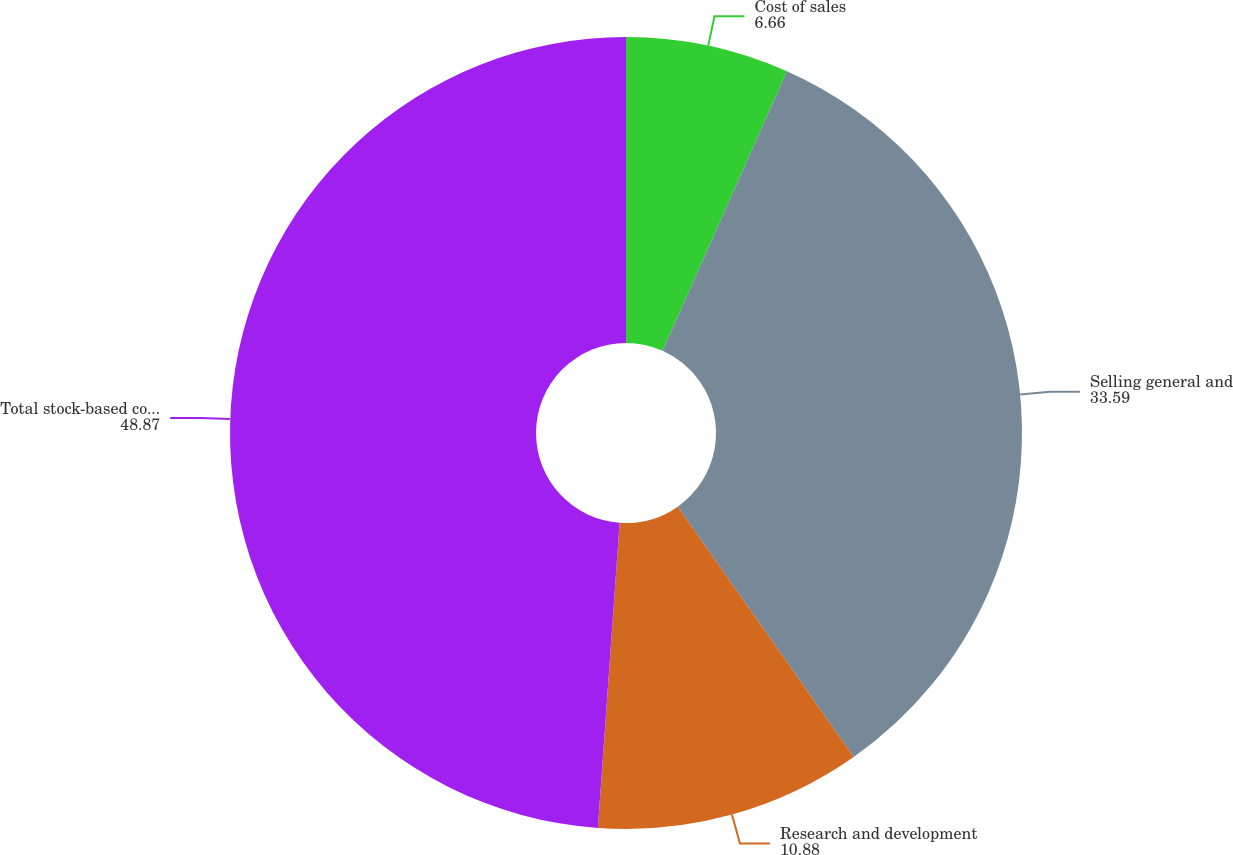<chart> <loc_0><loc_0><loc_500><loc_500><pie_chart><fcel>Cost of sales<fcel>Selling general and<fcel>Research and development<fcel>Total stock-based compensation<nl><fcel>6.66%<fcel>33.59%<fcel>10.88%<fcel>48.87%<nl></chart> 